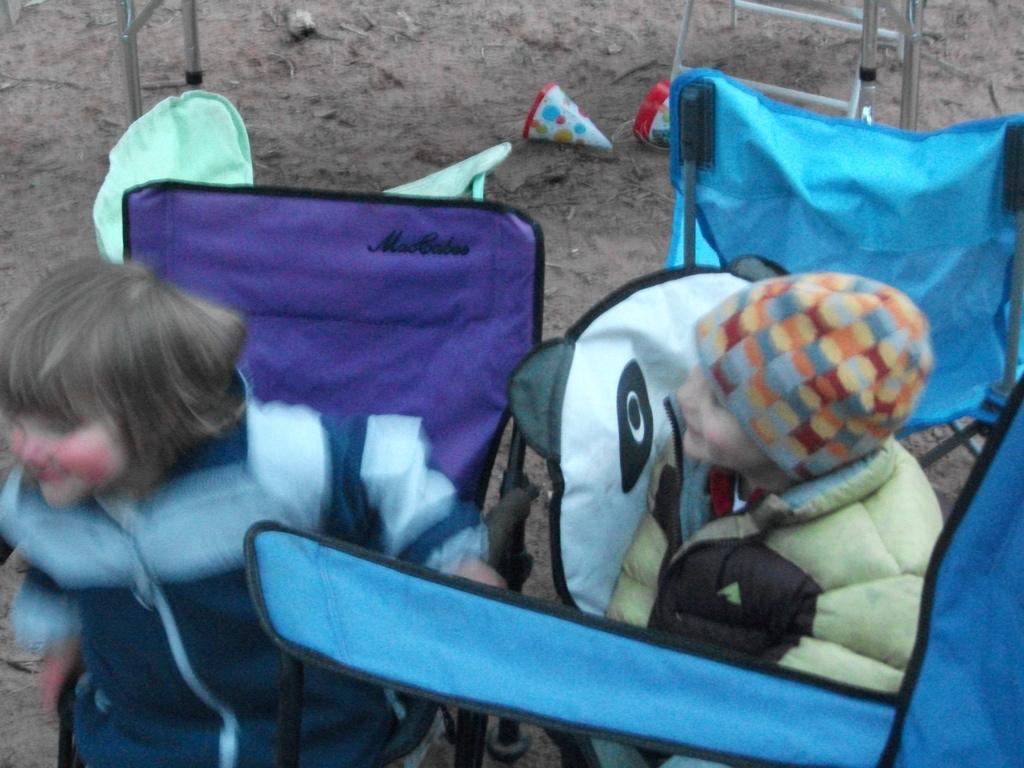In one or two sentences, can you explain what this image depicts? This image is taken outdoors. In the background there is the ground and there are a few objects on the ground. In the middle of the image there are two kids standing on the ground and there are two chairs. 